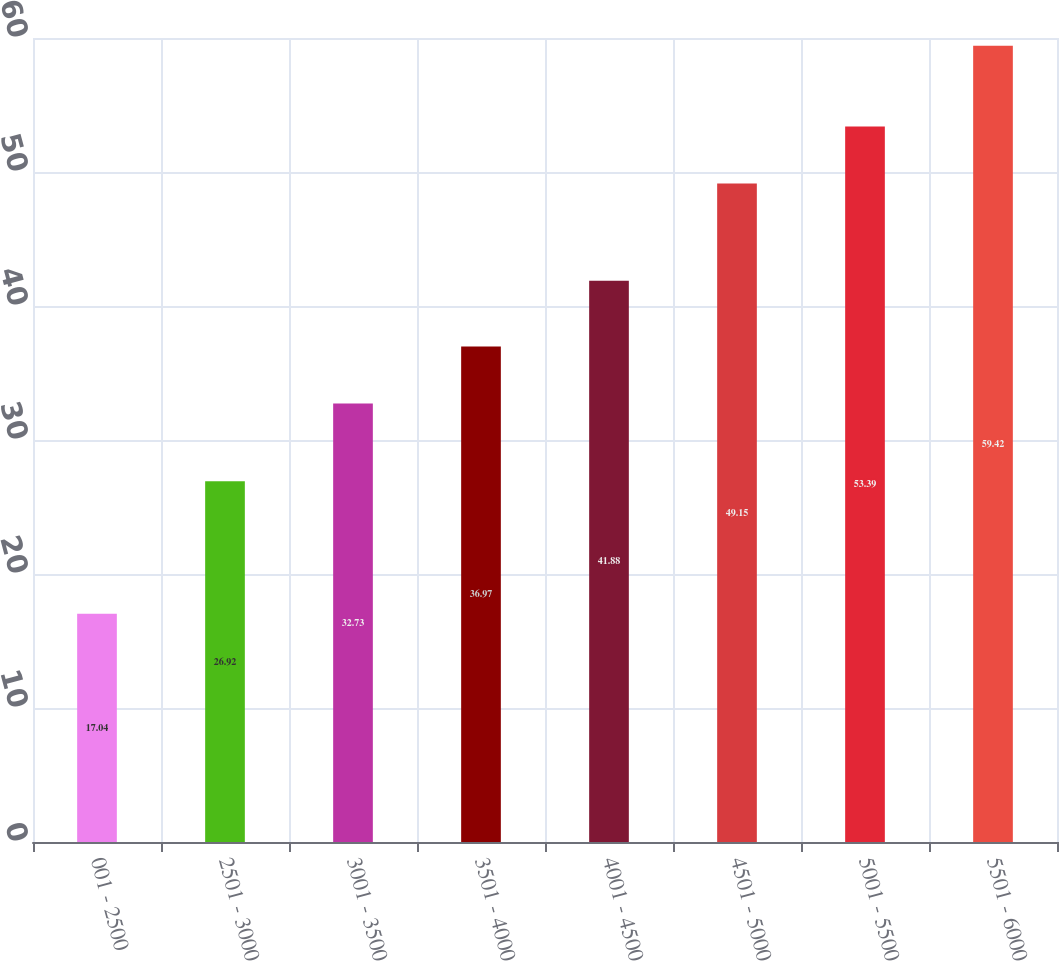Convert chart to OTSL. <chart><loc_0><loc_0><loc_500><loc_500><bar_chart><fcel>001 - 2500<fcel>2501 - 3000<fcel>3001 - 3500<fcel>3501 - 4000<fcel>4001 - 4500<fcel>4501 - 5000<fcel>5001 - 5500<fcel>5501 - 6000<nl><fcel>17.04<fcel>26.92<fcel>32.73<fcel>36.97<fcel>41.88<fcel>49.15<fcel>53.39<fcel>59.42<nl></chart> 